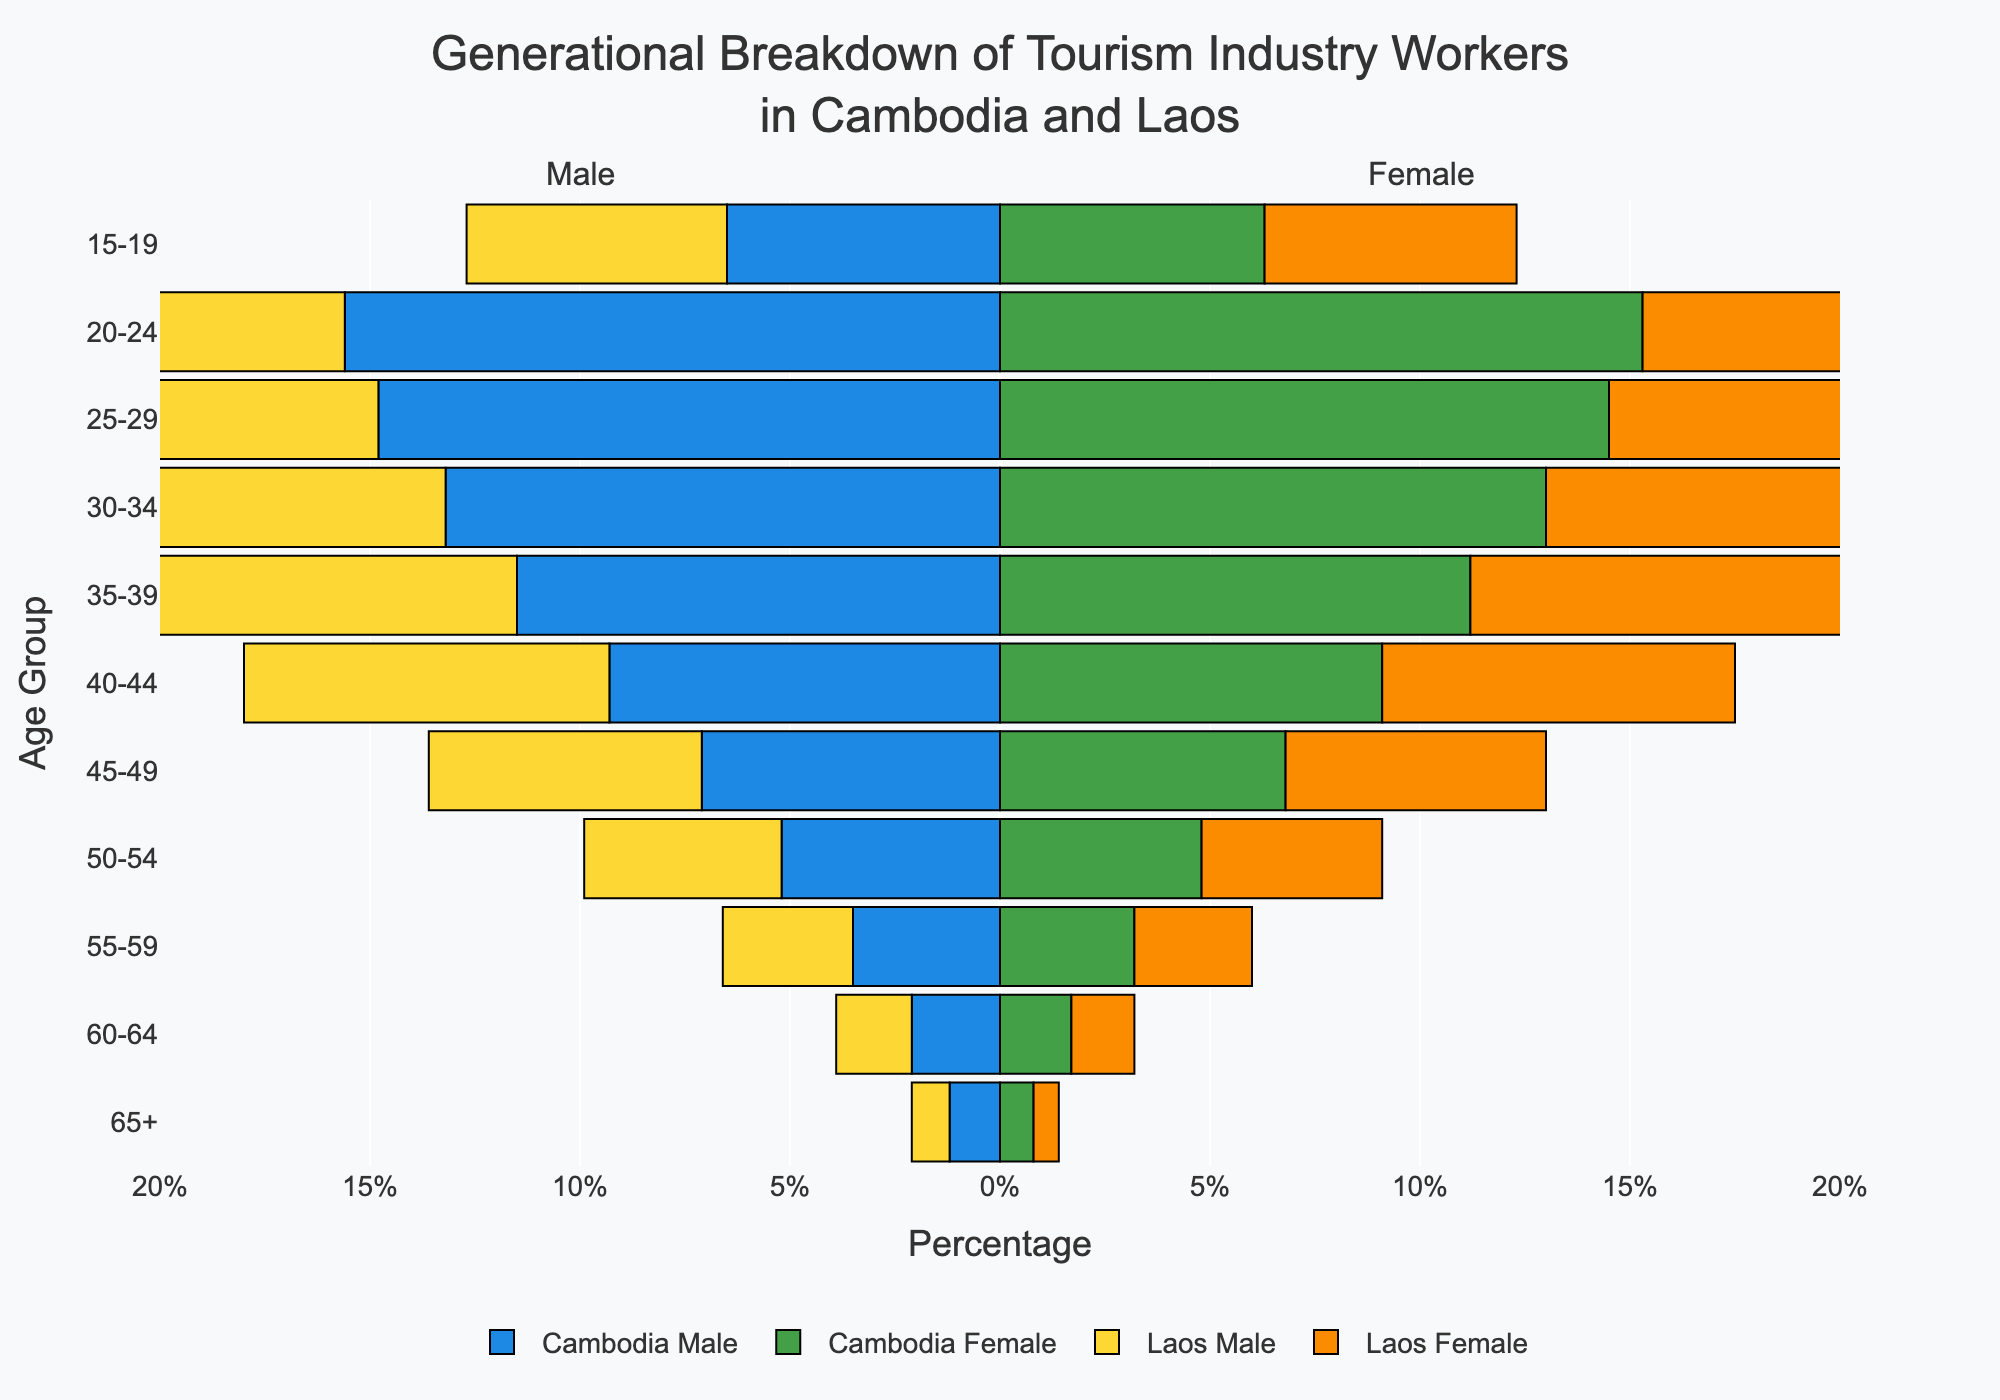What's the title of the figure? The title is located at the top of the figure. It reads: "Generational Breakdown of Tourism Industry Workers in Cambodia and Laos"
Answer: Generational Breakdown of Tourism Industry Workers in Cambodia and Laos What is the age group with the highest percentage representation in the tourism industry in Cambodia? By observing the largest bars for both males and females, the age group 20-24 has the highest percentage, with males at 15.6% and females at 15.3%
Answer: 20-24 Which age group has a greater percentage of female tourism industry workers in Cambodia compared to Laos? Comparing the bars for females in each age group between Cambodia and Laos, the age groups 60-64, 55-59, and 50-54 have a higher percentage in Cambodia
Answer: 60-64, 55-59, 50-54 What is the total combined percentage for Cambodian male workers aged 30-34 and 35-39? Summing the percentages for males in these age ranges: 30-34 is 13.2% and 35-39 is 11.5%. So, 13.2 + 11.5 = 24.7%
Answer: 24.7% Compare the percentage of female tourism workers aged 40-44 in Cambodia to those in Laos. Which is higher? Looking at the bars representing females aged 40-44, Cambodia has 9.1% and Laos has 8.4%. Thus, Cambodia is higher.
Answer: Cambodia How does the percentage of male and female tourism workers in Laos aged 15-19 compare? For the age group 15-19 in Laos, males are at 6.2% and females are at 6.0%. So, males are slightly higher.
Answer: Males are higher Which country has a higher percentage of total tourism workers aged 45-49? Summing the percentages of males and females aged 45-49, Cambodia has 13.9% (7.1% male + 6.8% female), while Laos has 12.7% (6.5% male + 6.2% female). Thus, Cambodia has a higher percentage.
Answer: Cambodia What is the smallest percentage observed in any age group and gender for both countries? Observing the smallest bar in the figure for both countries and all genders, the smallest percentage is in Laos for females aged 65+, which is 0.6%
Answer: 0.6% What is the approximate difference in the percentage of male tourism workers aged 60-64 between Cambodia and Laos? The percentage of male workers aged 60-64 is 2.1% for Cambodia and 1.8% for Laos. The difference is 2.1% - 1.8% = 0.3%
Answer: 0.3% Compare the overall trend of employment percentages across age groups for males in Cambodia to that of males in Laos. Both countries show a similar trend with the younger age groups (20-24, 25-29) having the highest percentages and then gradually decreasing with older age groups.
Answer: Similar trend 